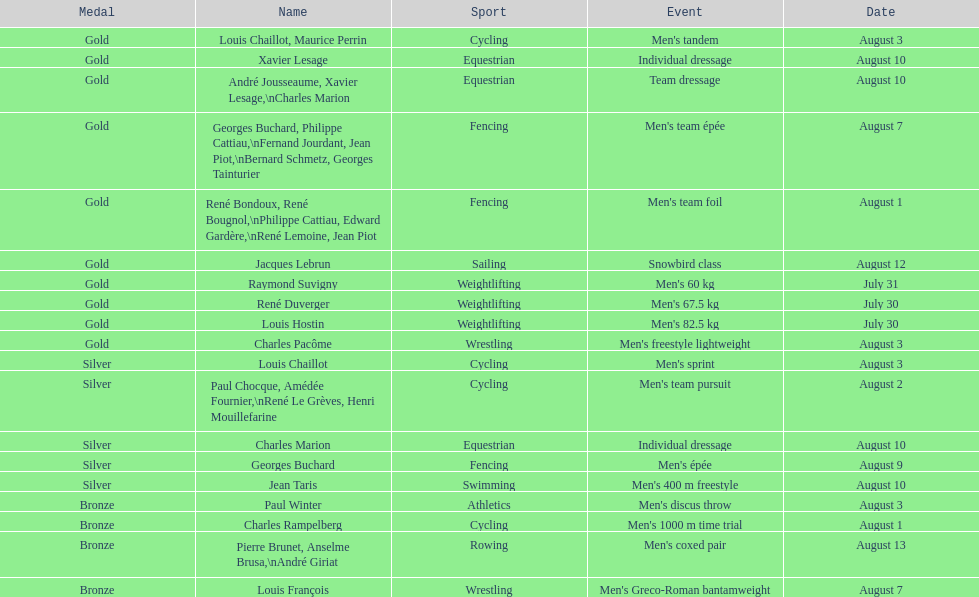How many medals were won after august 3? 9. 